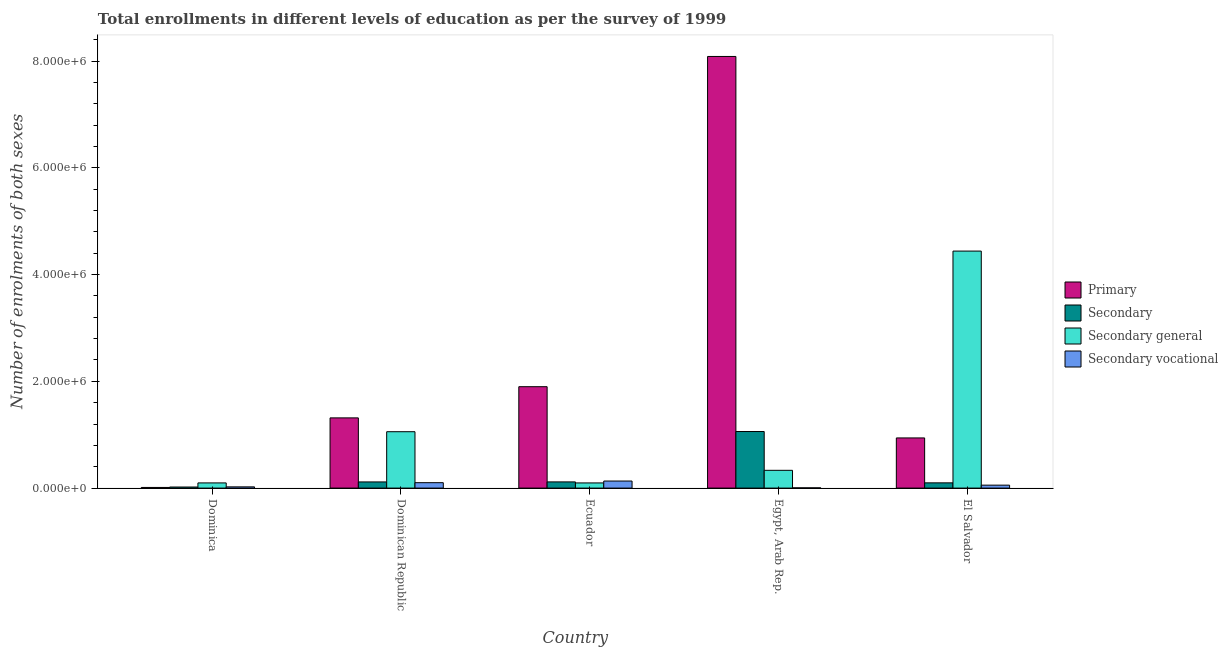How many different coloured bars are there?
Keep it short and to the point. 4. How many groups of bars are there?
Your response must be concise. 5. Are the number of bars per tick equal to the number of legend labels?
Your response must be concise. Yes. How many bars are there on the 5th tick from the left?
Offer a terse response. 4. What is the label of the 1st group of bars from the left?
Your answer should be compact. Dominica. What is the number of enrolments in secondary vocational education in El Salvador?
Give a very brief answer. 5.50e+04. Across all countries, what is the maximum number of enrolments in primary education?
Offer a very short reply. 8.09e+06. Across all countries, what is the minimum number of enrolments in secondary general education?
Your response must be concise. 9.66e+04. In which country was the number of enrolments in secondary education maximum?
Provide a short and direct response. Egypt, Arab Rep. In which country was the number of enrolments in secondary vocational education minimum?
Make the answer very short. Egypt, Arab Rep. What is the total number of enrolments in secondary education in the graph?
Ensure brevity in your answer.  1.41e+06. What is the difference between the number of enrolments in secondary vocational education in Dominica and that in Dominican Republic?
Ensure brevity in your answer.  -7.84e+04. What is the difference between the number of enrolments in secondary vocational education in Dominica and the number of enrolments in primary education in Egypt, Arab Rep.?
Give a very brief answer. -8.06e+06. What is the average number of enrolments in secondary vocational education per country?
Ensure brevity in your answer.  6.32e+04. What is the difference between the number of enrolments in secondary vocational education and number of enrolments in secondary general education in El Salvador?
Offer a very short reply. -4.39e+06. In how many countries, is the number of enrolments in secondary vocational education greater than 3600000 ?
Provide a short and direct response. 0. What is the ratio of the number of enrolments in primary education in Dominican Republic to that in Egypt, Arab Rep.?
Provide a succinct answer. 0.16. What is the difference between the highest and the second highest number of enrolments in secondary general education?
Your answer should be compact. 3.38e+06. What is the difference between the highest and the lowest number of enrolments in primary education?
Your answer should be very brief. 8.07e+06. Is it the case that in every country, the sum of the number of enrolments in primary education and number of enrolments in secondary general education is greater than the sum of number of enrolments in secondary vocational education and number of enrolments in secondary education?
Your answer should be very brief. No. What does the 3rd bar from the left in El Salvador represents?
Offer a terse response. Secondary general. What does the 1st bar from the right in Ecuador represents?
Ensure brevity in your answer.  Secondary vocational. Is it the case that in every country, the sum of the number of enrolments in primary education and number of enrolments in secondary education is greater than the number of enrolments in secondary general education?
Your response must be concise. No. What is the difference between two consecutive major ticks on the Y-axis?
Your answer should be very brief. 2.00e+06. How many legend labels are there?
Keep it short and to the point. 4. How are the legend labels stacked?
Your answer should be very brief. Vertical. What is the title of the graph?
Your answer should be compact. Total enrollments in different levels of education as per the survey of 1999. Does "Offering training" appear as one of the legend labels in the graph?
Offer a very short reply. No. What is the label or title of the Y-axis?
Provide a short and direct response. Number of enrolments of both sexes. What is the Number of enrolments of both sexes in Primary in Dominica?
Offer a very short reply. 1.20e+04. What is the Number of enrolments of both sexes of Secondary in Dominica?
Provide a succinct answer. 2.01e+04. What is the Number of enrolments of both sexes of Secondary general in Dominica?
Your answer should be compact. 9.70e+04. What is the Number of enrolments of both sexes of Secondary vocational in Dominica?
Keep it short and to the point. 2.29e+04. What is the Number of enrolments of both sexes in Primary in Dominican Republic?
Your answer should be compact. 1.32e+06. What is the Number of enrolments of both sexes in Secondary in Dominican Republic?
Ensure brevity in your answer.  1.15e+05. What is the Number of enrolments of both sexes of Secondary general in Dominican Republic?
Keep it short and to the point. 1.06e+06. What is the Number of enrolments of both sexes of Secondary vocational in Dominican Republic?
Offer a very short reply. 1.01e+05. What is the Number of enrolments of both sexes of Primary in Ecuador?
Keep it short and to the point. 1.90e+06. What is the Number of enrolments of both sexes in Secondary in Ecuador?
Offer a terse response. 1.16e+05. What is the Number of enrolments of both sexes in Secondary general in Ecuador?
Make the answer very short. 9.66e+04. What is the Number of enrolments of both sexes of Secondary vocational in Ecuador?
Provide a short and direct response. 1.32e+05. What is the Number of enrolments of both sexes of Primary in Egypt, Arab Rep.?
Your answer should be very brief. 8.09e+06. What is the Number of enrolments of both sexes in Secondary in Egypt, Arab Rep.?
Provide a short and direct response. 1.06e+06. What is the Number of enrolments of both sexes in Secondary general in Egypt, Arab Rep.?
Ensure brevity in your answer.  3.33e+05. What is the Number of enrolments of both sexes in Secondary vocational in Egypt, Arab Rep.?
Provide a short and direct response. 4453. What is the Number of enrolments of both sexes of Primary in El Salvador?
Make the answer very short. 9.40e+05. What is the Number of enrolments of both sexes in Secondary in El Salvador?
Offer a terse response. 9.83e+04. What is the Number of enrolments of both sexes of Secondary general in El Salvador?
Make the answer very short. 4.44e+06. What is the Number of enrolments of both sexes of Secondary vocational in El Salvador?
Keep it short and to the point. 5.50e+04. Across all countries, what is the maximum Number of enrolments of both sexes in Primary?
Ensure brevity in your answer.  8.09e+06. Across all countries, what is the maximum Number of enrolments of both sexes of Secondary?
Offer a very short reply. 1.06e+06. Across all countries, what is the maximum Number of enrolments of both sexes of Secondary general?
Give a very brief answer. 4.44e+06. Across all countries, what is the maximum Number of enrolments of both sexes in Secondary vocational?
Make the answer very short. 1.32e+05. Across all countries, what is the minimum Number of enrolments of both sexes in Primary?
Offer a very short reply. 1.20e+04. Across all countries, what is the minimum Number of enrolments of both sexes in Secondary?
Your answer should be very brief. 2.01e+04. Across all countries, what is the minimum Number of enrolments of both sexes in Secondary general?
Keep it short and to the point. 9.66e+04. Across all countries, what is the minimum Number of enrolments of both sexes of Secondary vocational?
Provide a short and direct response. 4453. What is the total Number of enrolments of both sexes in Primary in the graph?
Ensure brevity in your answer.  1.23e+07. What is the total Number of enrolments of both sexes in Secondary in the graph?
Your answer should be compact. 1.41e+06. What is the total Number of enrolments of both sexes of Secondary general in the graph?
Your answer should be very brief. 6.02e+06. What is the total Number of enrolments of both sexes in Secondary vocational in the graph?
Make the answer very short. 3.16e+05. What is the difference between the Number of enrolments of both sexes of Primary in Dominica and that in Dominican Republic?
Your response must be concise. -1.30e+06. What is the difference between the Number of enrolments of both sexes of Secondary in Dominica and that in Dominican Republic?
Your answer should be compact. -9.53e+04. What is the difference between the Number of enrolments of both sexes of Secondary general in Dominica and that in Dominican Republic?
Make the answer very short. -9.59e+05. What is the difference between the Number of enrolments of both sexes in Secondary vocational in Dominica and that in Dominican Republic?
Offer a very short reply. -7.84e+04. What is the difference between the Number of enrolments of both sexes in Primary in Dominica and that in Ecuador?
Your answer should be compact. -1.89e+06. What is the difference between the Number of enrolments of both sexes in Secondary in Dominica and that in Ecuador?
Your answer should be compact. -9.58e+04. What is the difference between the Number of enrolments of both sexes in Secondary general in Dominica and that in Ecuador?
Provide a succinct answer. 421. What is the difference between the Number of enrolments of both sexes in Secondary vocational in Dominica and that in Ecuador?
Offer a terse response. -1.09e+05. What is the difference between the Number of enrolments of both sexes of Primary in Dominica and that in Egypt, Arab Rep.?
Your answer should be very brief. -8.07e+06. What is the difference between the Number of enrolments of both sexes of Secondary in Dominica and that in Egypt, Arab Rep.?
Offer a terse response. -1.04e+06. What is the difference between the Number of enrolments of both sexes in Secondary general in Dominica and that in Egypt, Arab Rep.?
Provide a succinct answer. -2.36e+05. What is the difference between the Number of enrolments of both sexes of Secondary vocational in Dominica and that in Egypt, Arab Rep.?
Ensure brevity in your answer.  1.85e+04. What is the difference between the Number of enrolments of both sexes in Primary in Dominica and that in El Salvador?
Ensure brevity in your answer.  -9.28e+05. What is the difference between the Number of enrolments of both sexes of Secondary in Dominica and that in El Salvador?
Give a very brief answer. -7.82e+04. What is the difference between the Number of enrolments of both sexes in Secondary general in Dominica and that in El Salvador?
Give a very brief answer. -4.34e+06. What is the difference between the Number of enrolments of both sexes of Secondary vocational in Dominica and that in El Salvador?
Keep it short and to the point. -3.21e+04. What is the difference between the Number of enrolments of both sexes of Primary in Dominican Republic and that in Ecuador?
Offer a terse response. -5.84e+05. What is the difference between the Number of enrolments of both sexes in Secondary in Dominican Republic and that in Ecuador?
Your response must be concise. -492. What is the difference between the Number of enrolments of both sexes in Secondary general in Dominican Republic and that in Ecuador?
Ensure brevity in your answer.  9.60e+05. What is the difference between the Number of enrolments of both sexes in Secondary vocational in Dominican Republic and that in Ecuador?
Give a very brief answer. -3.07e+04. What is the difference between the Number of enrolments of both sexes of Primary in Dominican Republic and that in Egypt, Arab Rep.?
Ensure brevity in your answer.  -6.77e+06. What is the difference between the Number of enrolments of both sexes in Secondary in Dominican Republic and that in Egypt, Arab Rep.?
Keep it short and to the point. -9.44e+05. What is the difference between the Number of enrolments of both sexes in Secondary general in Dominican Republic and that in Egypt, Arab Rep.?
Your response must be concise. 7.24e+05. What is the difference between the Number of enrolments of both sexes in Secondary vocational in Dominican Republic and that in Egypt, Arab Rep.?
Provide a short and direct response. 9.69e+04. What is the difference between the Number of enrolments of both sexes in Primary in Dominican Republic and that in El Salvador?
Provide a succinct answer. 3.75e+05. What is the difference between the Number of enrolments of both sexes of Secondary in Dominican Republic and that in El Salvador?
Give a very brief answer. 1.71e+04. What is the difference between the Number of enrolments of both sexes in Secondary general in Dominican Republic and that in El Salvador?
Provide a succinct answer. -3.38e+06. What is the difference between the Number of enrolments of both sexes of Secondary vocational in Dominican Republic and that in El Salvador?
Make the answer very short. 4.63e+04. What is the difference between the Number of enrolments of both sexes in Primary in Ecuador and that in Egypt, Arab Rep.?
Provide a short and direct response. -6.19e+06. What is the difference between the Number of enrolments of both sexes of Secondary in Ecuador and that in Egypt, Arab Rep.?
Offer a terse response. -9.44e+05. What is the difference between the Number of enrolments of both sexes of Secondary general in Ecuador and that in Egypt, Arab Rep.?
Ensure brevity in your answer.  -2.36e+05. What is the difference between the Number of enrolments of both sexes of Secondary vocational in Ecuador and that in Egypt, Arab Rep.?
Offer a very short reply. 1.28e+05. What is the difference between the Number of enrolments of both sexes in Primary in Ecuador and that in El Salvador?
Provide a short and direct response. 9.60e+05. What is the difference between the Number of enrolments of both sexes of Secondary in Ecuador and that in El Salvador?
Provide a succinct answer. 1.76e+04. What is the difference between the Number of enrolments of both sexes of Secondary general in Ecuador and that in El Salvador?
Give a very brief answer. -4.34e+06. What is the difference between the Number of enrolments of both sexes of Secondary vocational in Ecuador and that in El Salvador?
Offer a very short reply. 7.70e+04. What is the difference between the Number of enrolments of both sexes of Primary in Egypt, Arab Rep. and that in El Salvador?
Your answer should be compact. 7.15e+06. What is the difference between the Number of enrolments of both sexes of Secondary in Egypt, Arab Rep. and that in El Salvador?
Ensure brevity in your answer.  9.61e+05. What is the difference between the Number of enrolments of both sexes of Secondary general in Egypt, Arab Rep. and that in El Salvador?
Ensure brevity in your answer.  -4.11e+06. What is the difference between the Number of enrolments of both sexes in Secondary vocational in Egypt, Arab Rep. and that in El Salvador?
Offer a very short reply. -5.06e+04. What is the difference between the Number of enrolments of both sexes of Primary in Dominica and the Number of enrolments of both sexes of Secondary in Dominican Republic?
Provide a succinct answer. -1.03e+05. What is the difference between the Number of enrolments of both sexes in Primary in Dominica and the Number of enrolments of both sexes in Secondary general in Dominican Republic?
Ensure brevity in your answer.  -1.04e+06. What is the difference between the Number of enrolments of both sexes of Primary in Dominica and the Number of enrolments of both sexes of Secondary vocational in Dominican Republic?
Offer a terse response. -8.93e+04. What is the difference between the Number of enrolments of both sexes in Secondary in Dominica and the Number of enrolments of both sexes in Secondary general in Dominican Republic?
Your response must be concise. -1.04e+06. What is the difference between the Number of enrolments of both sexes of Secondary in Dominica and the Number of enrolments of both sexes of Secondary vocational in Dominican Republic?
Your response must be concise. -8.13e+04. What is the difference between the Number of enrolments of both sexes in Secondary general in Dominica and the Number of enrolments of both sexes in Secondary vocational in Dominican Republic?
Give a very brief answer. -4373. What is the difference between the Number of enrolments of both sexes in Primary in Dominica and the Number of enrolments of both sexes in Secondary in Ecuador?
Provide a short and direct response. -1.04e+05. What is the difference between the Number of enrolments of both sexes in Primary in Dominica and the Number of enrolments of both sexes in Secondary general in Ecuador?
Give a very brief answer. -8.45e+04. What is the difference between the Number of enrolments of both sexes of Primary in Dominica and the Number of enrolments of both sexes of Secondary vocational in Ecuador?
Your answer should be very brief. -1.20e+05. What is the difference between the Number of enrolments of both sexes of Secondary in Dominica and the Number of enrolments of both sexes of Secondary general in Ecuador?
Ensure brevity in your answer.  -7.65e+04. What is the difference between the Number of enrolments of both sexes of Secondary in Dominica and the Number of enrolments of both sexes of Secondary vocational in Ecuador?
Give a very brief answer. -1.12e+05. What is the difference between the Number of enrolments of both sexes in Secondary general in Dominica and the Number of enrolments of both sexes in Secondary vocational in Ecuador?
Provide a succinct answer. -3.51e+04. What is the difference between the Number of enrolments of both sexes in Primary in Dominica and the Number of enrolments of both sexes in Secondary in Egypt, Arab Rep.?
Provide a short and direct response. -1.05e+06. What is the difference between the Number of enrolments of both sexes in Primary in Dominica and the Number of enrolments of both sexes in Secondary general in Egypt, Arab Rep.?
Keep it short and to the point. -3.21e+05. What is the difference between the Number of enrolments of both sexes in Primary in Dominica and the Number of enrolments of both sexes in Secondary vocational in Egypt, Arab Rep.?
Provide a succinct answer. 7591. What is the difference between the Number of enrolments of both sexes of Secondary in Dominica and the Number of enrolments of both sexes of Secondary general in Egypt, Arab Rep.?
Give a very brief answer. -3.13e+05. What is the difference between the Number of enrolments of both sexes of Secondary in Dominica and the Number of enrolments of both sexes of Secondary vocational in Egypt, Arab Rep.?
Offer a terse response. 1.56e+04. What is the difference between the Number of enrolments of both sexes in Secondary general in Dominica and the Number of enrolments of both sexes in Secondary vocational in Egypt, Arab Rep.?
Ensure brevity in your answer.  9.25e+04. What is the difference between the Number of enrolments of both sexes in Primary in Dominica and the Number of enrolments of both sexes in Secondary in El Salvador?
Your answer should be very brief. -8.62e+04. What is the difference between the Number of enrolments of both sexes in Primary in Dominica and the Number of enrolments of both sexes in Secondary general in El Salvador?
Offer a very short reply. -4.43e+06. What is the difference between the Number of enrolments of both sexes in Primary in Dominica and the Number of enrolments of both sexes in Secondary vocational in El Salvador?
Your response must be concise. -4.30e+04. What is the difference between the Number of enrolments of both sexes in Secondary in Dominica and the Number of enrolments of both sexes in Secondary general in El Salvador?
Make the answer very short. -4.42e+06. What is the difference between the Number of enrolments of both sexes in Secondary in Dominica and the Number of enrolments of both sexes in Secondary vocational in El Salvador?
Keep it short and to the point. -3.50e+04. What is the difference between the Number of enrolments of both sexes of Secondary general in Dominica and the Number of enrolments of both sexes of Secondary vocational in El Salvador?
Your answer should be compact. 4.19e+04. What is the difference between the Number of enrolments of both sexes in Primary in Dominican Republic and the Number of enrolments of both sexes in Secondary in Ecuador?
Your response must be concise. 1.20e+06. What is the difference between the Number of enrolments of both sexes of Primary in Dominican Republic and the Number of enrolments of both sexes of Secondary general in Ecuador?
Your response must be concise. 1.22e+06. What is the difference between the Number of enrolments of both sexes of Primary in Dominican Republic and the Number of enrolments of both sexes of Secondary vocational in Ecuador?
Provide a succinct answer. 1.18e+06. What is the difference between the Number of enrolments of both sexes of Secondary in Dominican Republic and the Number of enrolments of both sexes of Secondary general in Ecuador?
Keep it short and to the point. 1.88e+04. What is the difference between the Number of enrolments of both sexes of Secondary in Dominican Republic and the Number of enrolments of both sexes of Secondary vocational in Ecuador?
Your response must be concise. -1.67e+04. What is the difference between the Number of enrolments of both sexes of Secondary general in Dominican Republic and the Number of enrolments of both sexes of Secondary vocational in Ecuador?
Provide a short and direct response. 9.24e+05. What is the difference between the Number of enrolments of both sexes in Primary in Dominican Republic and the Number of enrolments of both sexes in Secondary in Egypt, Arab Rep.?
Make the answer very short. 2.56e+05. What is the difference between the Number of enrolments of both sexes in Primary in Dominican Republic and the Number of enrolments of both sexes in Secondary general in Egypt, Arab Rep.?
Your response must be concise. 9.83e+05. What is the difference between the Number of enrolments of both sexes of Primary in Dominican Republic and the Number of enrolments of both sexes of Secondary vocational in Egypt, Arab Rep.?
Your response must be concise. 1.31e+06. What is the difference between the Number of enrolments of both sexes in Secondary in Dominican Republic and the Number of enrolments of both sexes in Secondary general in Egypt, Arab Rep.?
Your answer should be very brief. -2.17e+05. What is the difference between the Number of enrolments of both sexes in Secondary in Dominican Republic and the Number of enrolments of both sexes in Secondary vocational in Egypt, Arab Rep.?
Provide a short and direct response. 1.11e+05. What is the difference between the Number of enrolments of both sexes of Secondary general in Dominican Republic and the Number of enrolments of both sexes of Secondary vocational in Egypt, Arab Rep.?
Your answer should be compact. 1.05e+06. What is the difference between the Number of enrolments of both sexes in Primary in Dominican Republic and the Number of enrolments of both sexes in Secondary in El Salvador?
Your answer should be very brief. 1.22e+06. What is the difference between the Number of enrolments of both sexes in Primary in Dominican Republic and the Number of enrolments of both sexes in Secondary general in El Salvador?
Your answer should be compact. -3.12e+06. What is the difference between the Number of enrolments of both sexes of Primary in Dominican Republic and the Number of enrolments of both sexes of Secondary vocational in El Salvador?
Your answer should be compact. 1.26e+06. What is the difference between the Number of enrolments of both sexes in Secondary in Dominican Republic and the Number of enrolments of both sexes in Secondary general in El Salvador?
Your response must be concise. -4.32e+06. What is the difference between the Number of enrolments of both sexes in Secondary in Dominican Republic and the Number of enrolments of both sexes in Secondary vocational in El Salvador?
Offer a terse response. 6.03e+04. What is the difference between the Number of enrolments of both sexes in Secondary general in Dominican Republic and the Number of enrolments of both sexes in Secondary vocational in El Salvador?
Ensure brevity in your answer.  1.00e+06. What is the difference between the Number of enrolments of both sexes of Primary in Ecuador and the Number of enrolments of both sexes of Secondary in Egypt, Arab Rep.?
Your answer should be very brief. 8.40e+05. What is the difference between the Number of enrolments of both sexes in Primary in Ecuador and the Number of enrolments of both sexes in Secondary general in Egypt, Arab Rep.?
Offer a terse response. 1.57e+06. What is the difference between the Number of enrolments of both sexes of Primary in Ecuador and the Number of enrolments of both sexes of Secondary vocational in Egypt, Arab Rep.?
Ensure brevity in your answer.  1.90e+06. What is the difference between the Number of enrolments of both sexes of Secondary in Ecuador and the Number of enrolments of both sexes of Secondary general in Egypt, Arab Rep.?
Make the answer very short. -2.17e+05. What is the difference between the Number of enrolments of both sexes in Secondary in Ecuador and the Number of enrolments of both sexes in Secondary vocational in Egypt, Arab Rep.?
Your response must be concise. 1.11e+05. What is the difference between the Number of enrolments of both sexes of Secondary general in Ecuador and the Number of enrolments of both sexes of Secondary vocational in Egypt, Arab Rep.?
Keep it short and to the point. 9.21e+04. What is the difference between the Number of enrolments of both sexes of Primary in Ecuador and the Number of enrolments of both sexes of Secondary in El Salvador?
Your answer should be very brief. 1.80e+06. What is the difference between the Number of enrolments of both sexes in Primary in Ecuador and the Number of enrolments of both sexes in Secondary general in El Salvador?
Provide a short and direct response. -2.54e+06. What is the difference between the Number of enrolments of both sexes of Primary in Ecuador and the Number of enrolments of both sexes of Secondary vocational in El Salvador?
Offer a very short reply. 1.84e+06. What is the difference between the Number of enrolments of both sexes in Secondary in Ecuador and the Number of enrolments of both sexes in Secondary general in El Salvador?
Offer a very short reply. -4.32e+06. What is the difference between the Number of enrolments of both sexes of Secondary in Ecuador and the Number of enrolments of both sexes of Secondary vocational in El Salvador?
Your answer should be very brief. 6.08e+04. What is the difference between the Number of enrolments of both sexes in Secondary general in Ecuador and the Number of enrolments of both sexes in Secondary vocational in El Salvador?
Your answer should be very brief. 4.15e+04. What is the difference between the Number of enrolments of both sexes of Primary in Egypt, Arab Rep. and the Number of enrolments of both sexes of Secondary in El Salvador?
Provide a succinct answer. 7.99e+06. What is the difference between the Number of enrolments of both sexes in Primary in Egypt, Arab Rep. and the Number of enrolments of both sexes in Secondary general in El Salvador?
Provide a succinct answer. 3.65e+06. What is the difference between the Number of enrolments of both sexes of Primary in Egypt, Arab Rep. and the Number of enrolments of both sexes of Secondary vocational in El Salvador?
Keep it short and to the point. 8.03e+06. What is the difference between the Number of enrolments of both sexes in Secondary in Egypt, Arab Rep. and the Number of enrolments of both sexes in Secondary general in El Salvador?
Ensure brevity in your answer.  -3.38e+06. What is the difference between the Number of enrolments of both sexes of Secondary in Egypt, Arab Rep. and the Number of enrolments of both sexes of Secondary vocational in El Salvador?
Ensure brevity in your answer.  1.00e+06. What is the difference between the Number of enrolments of both sexes in Secondary general in Egypt, Arab Rep. and the Number of enrolments of both sexes in Secondary vocational in El Salvador?
Your response must be concise. 2.78e+05. What is the average Number of enrolments of both sexes of Primary per country?
Your response must be concise. 2.45e+06. What is the average Number of enrolments of both sexes of Secondary per country?
Make the answer very short. 2.82e+05. What is the average Number of enrolments of both sexes in Secondary general per country?
Keep it short and to the point. 1.20e+06. What is the average Number of enrolments of both sexes in Secondary vocational per country?
Your answer should be compact. 6.32e+04. What is the difference between the Number of enrolments of both sexes of Primary and Number of enrolments of both sexes of Secondary in Dominica?
Offer a very short reply. -8012. What is the difference between the Number of enrolments of both sexes of Primary and Number of enrolments of both sexes of Secondary general in Dominica?
Ensure brevity in your answer.  -8.49e+04. What is the difference between the Number of enrolments of both sexes in Primary and Number of enrolments of both sexes in Secondary vocational in Dominica?
Keep it short and to the point. -1.09e+04. What is the difference between the Number of enrolments of both sexes of Secondary and Number of enrolments of both sexes of Secondary general in Dominica?
Your answer should be very brief. -7.69e+04. What is the difference between the Number of enrolments of both sexes in Secondary and Number of enrolments of both sexes in Secondary vocational in Dominica?
Your answer should be compact. -2891. What is the difference between the Number of enrolments of both sexes in Secondary general and Number of enrolments of both sexes in Secondary vocational in Dominica?
Offer a very short reply. 7.40e+04. What is the difference between the Number of enrolments of both sexes of Primary and Number of enrolments of both sexes of Secondary in Dominican Republic?
Offer a very short reply. 1.20e+06. What is the difference between the Number of enrolments of both sexes in Primary and Number of enrolments of both sexes in Secondary general in Dominican Republic?
Provide a succinct answer. 2.59e+05. What is the difference between the Number of enrolments of both sexes of Primary and Number of enrolments of both sexes of Secondary vocational in Dominican Republic?
Ensure brevity in your answer.  1.21e+06. What is the difference between the Number of enrolments of both sexes of Secondary and Number of enrolments of both sexes of Secondary general in Dominican Republic?
Your answer should be compact. -9.41e+05. What is the difference between the Number of enrolments of both sexes in Secondary and Number of enrolments of both sexes in Secondary vocational in Dominican Republic?
Your answer should be very brief. 1.40e+04. What is the difference between the Number of enrolments of both sexes in Secondary general and Number of enrolments of both sexes in Secondary vocational in Dominican Republic?
Provide a short and direct response. 9.55e+05. What is the difference between the Number of enrolments of both sexes in Primary and Number of enrolments of both sexes in Secondary in Ecuador?
Ensure brevity in your answer.  1.78e+06. What is the difference between the Number of enrolments of both sexes in Primary and Number of enrolments of both sexes in Secondary general in Ecuador?
Ensure brevity in your answer.  1.80e+06. What is the difference between the Number of enrolments of both sexes in Primary and Number of enrolments of both sexes in Secondary vocational in Ecuador?
Your answer should be compact. 1.77e+06. What is the difference between the Number of enrolments of both sexes of Secondary and Number of enrolments of both sexes of Secondary general in Ecuador?
Offer a terse response. 1.93e+04. What is the difference between the Number of enrolments of both sexes in Secondary and Number of enrolments of both sexes in Secondary vocational in Ecuador?
Ensure brevity in your answer.  -1.62e+04. What is the difference between the Number of enrolments of both sexes of Secondary general and Number of enrolments of both sexes of Secondary vocational in Ecuador?
Provide a succinct answer. -3.55e+04. What is the difference between the Number of enrolments of both sexes in Primary and Number of enrolments of both sexes in Secondary in Egypt, Arab Rep.?
Your answer should be very brief. 7.03e+06. What is the difference between the Number of enrolments of both sexes of Primary and Number of enrolments of both sexes of Secondary general in Egypt, Arab Rep.?
Your answer should be very brief. 7.75e+06. What is the difference between the Number of enrolments of both sexes in Primary and Number of enrolments of both sexes in Secondary vocational in Egypt, Arab Rep.?
Offer a very short reply. 8.08e+06. What is the difference between the Number of enrolments of both sexes of Secondary and Number of enrolments of both sexes of Secondary general in Egypt, Arab Rep.?
Give a very brief answer. 7.27e+05. What is the difference between the Number of enrolments of both sexes in Secondary and Number of enrolments of both sexes in Secondary vocational in Egypt, Arab Rep.?
Provide a succinct answer. 1.06e+06. What is the difference between the Number of enrolments of both sexes of Secondary general and Number of enrolments of both sexes of Secondary vocational in Egypt, Arab Rep.?
Provide a succinct answer. 3.28e+05. What is the difference between the Number of enrolments of both sexes of Primary and Number of enrolments of both sexes of Secondary in El Salvador?
Your response must be concise. 8.42e+05. What is the difference between the Number of enrolments of both sexes in Primary and Number of enrolments of both sexes in Secondary general in El Salvador?
Your answer should be compact. -3.50e+06. What is the difference between the Number of enrolments of both sexes of Primary and Number of enrolments of both sexes of Secondary vocational in El Salvador?
Ensure brevity in your answer.  8.85e+05. What is the difference between the Number of enrolments of both sexes in Secondary and Number of enrolments of both sexes in Secondary general in El Salvador?
Your answer should be compact. -4.34e+06. What is the difference between the Number of enrolments of both sexes in Secondary and Number of enrolments of both sexes in Secondary vocational in El Salvador?
Your answer should be compact. 4.32e+04. What is the difference between the Number of enrolments of both sexes of Secondary general and Number of enrolments of both sexes of Secondary vocational in El Salvador?
Provide a succinct answer. 4.39e+06. What is the ratio of the Number of enrolments of both sexes in Primary in Dominica to that in Dominican Republic?
Make the answer very short. 0.01. What is the ratio of the Number of enrolments of both sexes of Secondary in Dominica to that in Dominican Republic?
Ensure brevity in your answer.  0.17. What is the ratio of the Number of enrolments of both sexes in Secondary general in Dominica to that in Dominican Republic?
Keep it short and to the point. 0.09. What is the ratio of the Number of enrolments of both sexes in Secondary vocational in Dominica to that in Dominican Republic?
Offer a very short reply. 0.23. What is the ratio of the Number of enrolments of both sexes of Primary in Dominica to that in Ecuador?
Your answer should be very brief. 0.01. What is the ratio of the Number of enrolments of both sexes of Secondary in Dominica to that in Ecuador?
Your answer should be compact. 0.17. What is the ratio of the Number of enrolments of both sexes in Secondary general in Dominica to that in Ecuador?
Provide a short and direct response. 1. What is the ratio of the Number of enrolments of both sexes in Secondary vocational in Dominica to that in Ecuador?
Provide a short and direct response. 0.17. What is the ratio of the Number of enrolments of both sexes of Primary in Dominica to that in Egypt, Arab Rep.?
Provide a succinct answer. 0. What is the ratio of the Number of enrolments of both sexes in Secondary in Dominica to that in Egypt, Arab Rep.?
Your response must be concise. 0.02. What is the ratio of the Number of enrolments of both sexes of Secondary general in Dominica to that in Egypt, Arab Rep.?
Offer a terse response. 0.29. What is the ratio of the Number of enrolments of both sexes in Secondary vocational in Dominica to that in Egypt, Arab Rep.?
Make the answer very short. 5.15. What is the ratio of the Number of enrolments of both sexes in Primary in Dominica to that in El Salvador?
Provide a succinct answer. 0.01. What is the ratio of the Number of enrolments of both sexes in Secondary in Dominica to that in El Salvador?
Your answer should be compact. 0.2. What is the ratio of the Number of enrolments of both sexes of Secondary general in Dominica to that in El Salvador?
Give a very brief answer. 0.02. What is the ratio of the Number of enrolments of both sexes in Secondary vocational in Dominica to that in El Salvador?
Offer a very short reply. 0.42. What is the ratio of the Number of enrolments of both sexes of Primary in Dominican Republic to that in Ecuador?
Offer a very short reply. 0.69. What is the ratio of the Number of enrolments of both sexes of Secondary in Dominican Republic to that in Ecuador?
Your answer should be compact. 1. What is the ratio of the Number of enrolments of both sexes of Secondary general in Dominican Republic to that in Ecuador?
Your response must be concise. 10.94. What is the ratio of the Number of enrolments of both sexes in Secondary vocational in Dominican Republic to that in Ecuador?
Keep it short and to the point. 0.77. What is the ratio of the Number of enrolments of both sexes of Primary in Dominican Republic to that in Egypt, Arab Rep.?
Your answer should be very brief. 0.16. What is the ratio of the Number of enrolments of both sexes in Secondary in Dominican Republic to that in Egypt, Arab Rep.?
Make the answer very short. 0.11. What is the ratio of the Number of enrolments of both sexes of Secondary general in Dominican Republic to that in Egypt, Arab Rep.?
Make the answer very short. 3.17. What is the ratio of the Number of enrolments of both sexes in Secondary vocational in Dominican Republic to that in Egypt, Arab Rep.?
Offer a terse response. 22.76. What is the ratio of the Number of enrolments of both sexes in Primary in Dominican Republic to that in El Salvador?
Your response must be concise. 1.4. What is the ratio of the Number of enrolments of both sexes in Secondary in Dominican Republic to that in El Salvador?
Give a very brief answer. 1.17. What is the ratio of the Number of enrolments of both sexes in Secondary general in Dominican Republic to that in El Salvador?
Give a very brief answer. 0.24. What is the ratio of the Number of enrolments of both sexes in Secondary vocational in Dominican Republic to that in El Salvador?
Provide a short and direct response. 1.84. What is the ratio of the Number of enrolments of both sexes in Primary in Ecuador to that in Egypt, Arab Rep.?
Provide a succinct answer. 0.23. What is the ratio of the Number of enrolments of both sexes of Secondary in Ecuador to that in Egypt, Arab Rep.?
Your response must be concise. 0.11. What is the ratio of the Number of enrolments of both sexes in Secondary general in Ecuador to that in Egypt, Arab Rep.?
Ensure brevity in your answer.  0.29. What is the ratio of the Number of enrolments of both sexes in Secondary vocational in Ecuador to that in Egypt, Arab Rep.?
Ensure brevity in your answer.  29.66. What is the ratio of the Number of enrolments of both sexes of Primary in Ecuador to that in El Salvador?
Make the answer very short. 2.02. What is the ratio of the Number of enrolments of both sexes of Secondary in Ecuador to that in El Salvador?
Your response must be concise. 1.18. What is the ratio of the Number of enrolments of both sexes in Secondary general in Ecuador to that in El Salvador?
Offer a very short reply. 0.02. What is the ratio of the Number of enrolments of both sexes in Secondary vocational in Ecuador to that in El Salvador?
Make the answer very short. 2.4. What is the ratio of the Number of enrolments of both sexes of Primary in Egypt, Arab Rep. to that in El Salvador?
Give a very brief answer. 8.6. What is the ratio of the Number of enrolments of both sexes of Secondary in Egypt, Arab Rep. to that in El Salvador?
Your answer should be compact. 10.78. What is the ratio of the Number of enrolments of both sexes of Secondary general in Egypt, Arab Rep. to that in El Salvador?
Provide a succinct answer. 0.07. What is the ratio of the Number of enrolments of both sexes in Secondary vocational in Egypt, Arab Rep. to that in El Salvador?
Make the answer very short. 0.08. What is the difference between the highest and the second highest Number of enrolments of both sexes of Primary?
Give a very brief answer. 6.19e+06. What is the difference between the highest and the second highest Number of enrolments of both sexes of Secondary?
Keep it short and to the point. 9.44e+05. What is the difference between the highest and the second highest Number of enrolments of both sexes of Secondary general?
Provide a short and direct response. 3.38e+06. What is the difference between the highest and the second highest Number of enrolments of both sexes in Secondary vocational?
Provide a short and direct response. 3.07e+04. What is the difference between the highest and the lowest Number of enrolments of both sexes of Primary?
Your answer should be very brief. 8.07e+06. What is the difference between the highest and the lowest Number of enrolments of both sexes in Secondary?
Ensure brevity in your answer.  1.04e+06. What is the difference between the highest and the lowest Number of enrolments of both sexes in Secondary general?
Provide a succinct answer. 4.34e+06. What is the difference between the highest and the lowest Number of enrolments of both sexes of Secondary vocational?
Your answer should be very brief. 1.28e+05. 